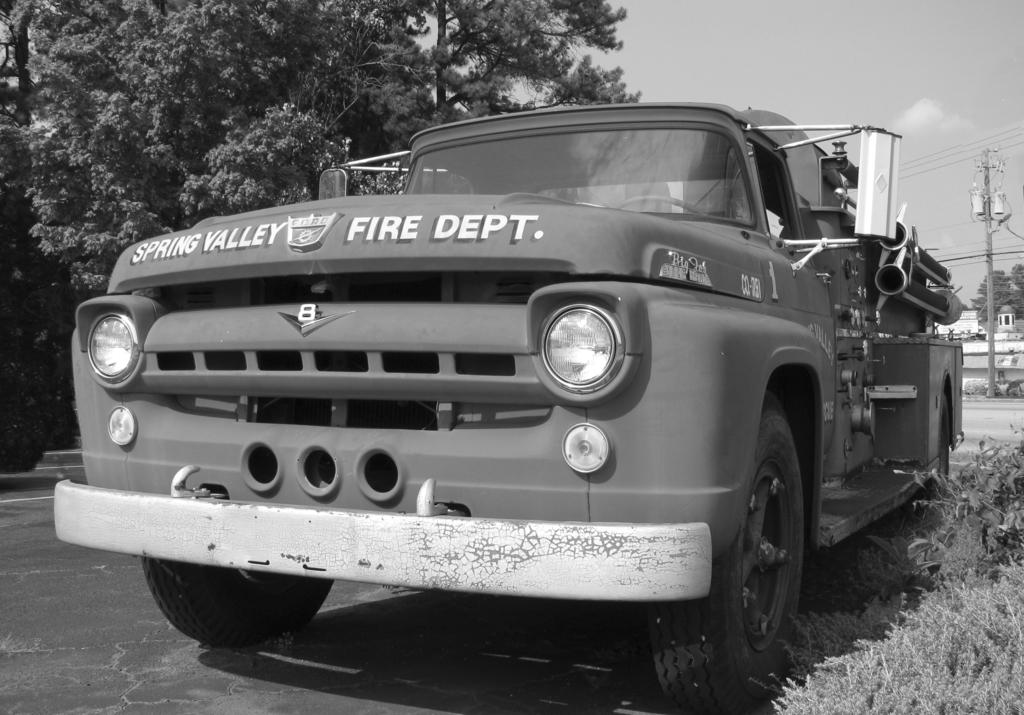What is on the road in the image? There is a vehicle on the road in the image. What can be seen on the vehicle? The headlights of the vehicle are visible. What type of vegetation is present in the image? There is grass and trees in the image. What man-made structures can be seen in the image? There is an electric pole, a building, and a road in the image. What is visible in the sky? The sky is visible in the image. What type of rhythm can be heard coming from the vehicle in the image? There is no indication of sound or rhythm in the image, as it only shows a vehicle on the road with visible headlights. 